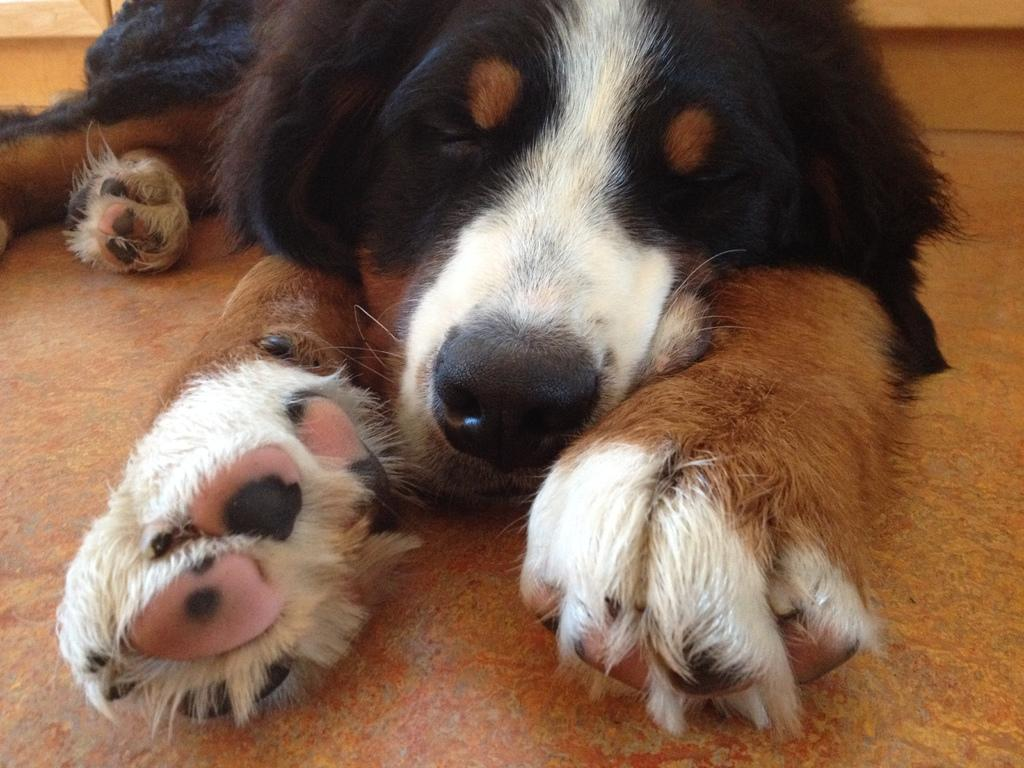What type of animal is present in the image? There is a dog in the image. How many rabbits can be seen playing with the dog in the image? There are no rabbits present in the image; it only features a dog. What type of drug is the dog taking in the image? There is no drug present in the image, as it only features a dog. 